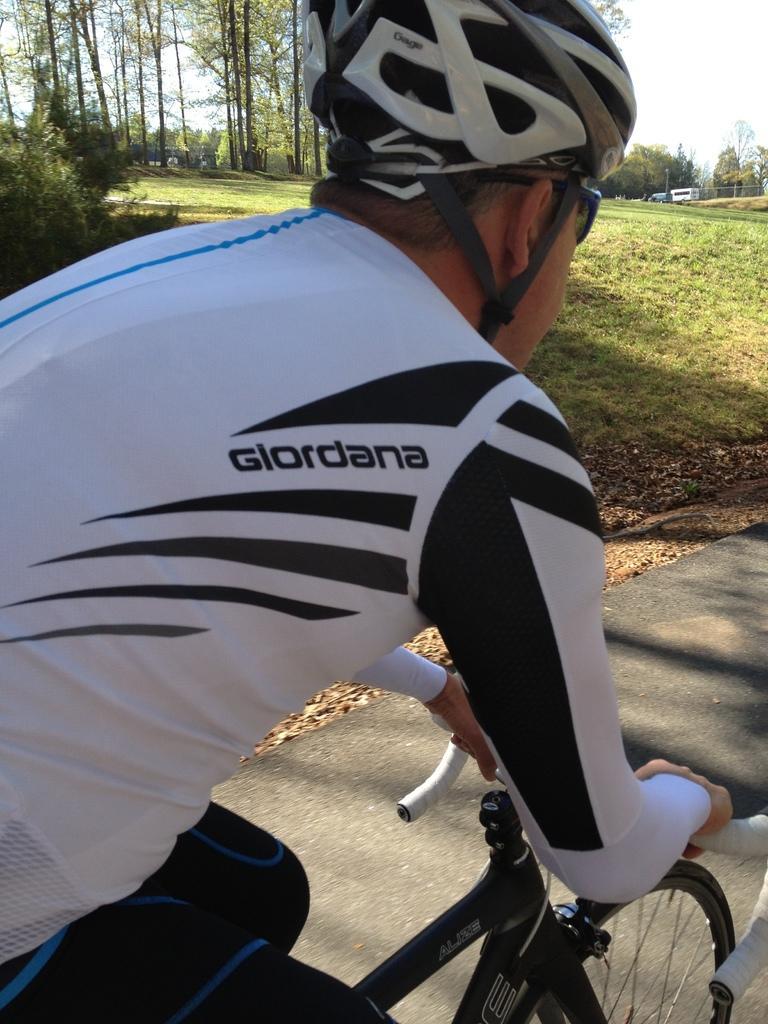Describe this image in one or two sentences. In the image there is a man with white t-shirt and helmet is riding a bicycle on the road. Behind him there are many trees and also there is grass on the ground. 